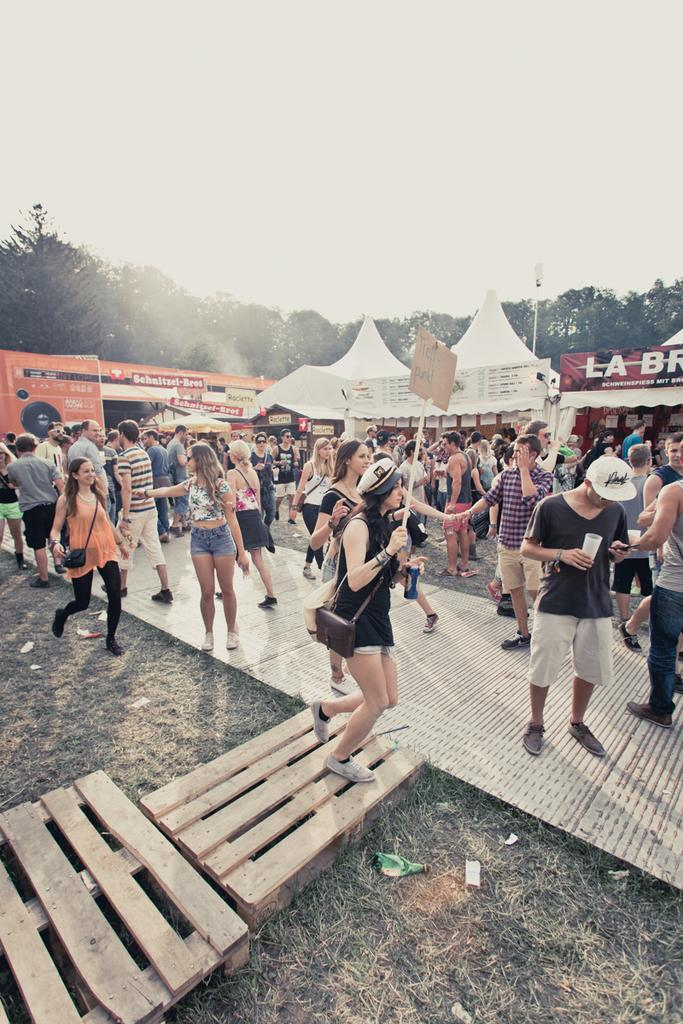What types of people are in the image? There are women and men in the image. What are the people doing in the image? The people are standing and walking on the road. What can be seen in the background of the image? There are tents in the background of the image, and trees are present behind the tents. What is visible above the scene? The sky is visible above the scene. What type of eggs can be seen in the image? There are no eggs present in the image. What brand of soda is being consumed by the people in the image? There is no soda visible in the image, and we cannot determine what the people might be consuming. 